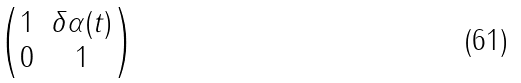<formula> <loc_0><loc_0><loc_500><loc_500>\begin{pmatrix} 1 & \delta \alpha ( t ) \\ 0 & 1 \end{pmatrix}</formula> 